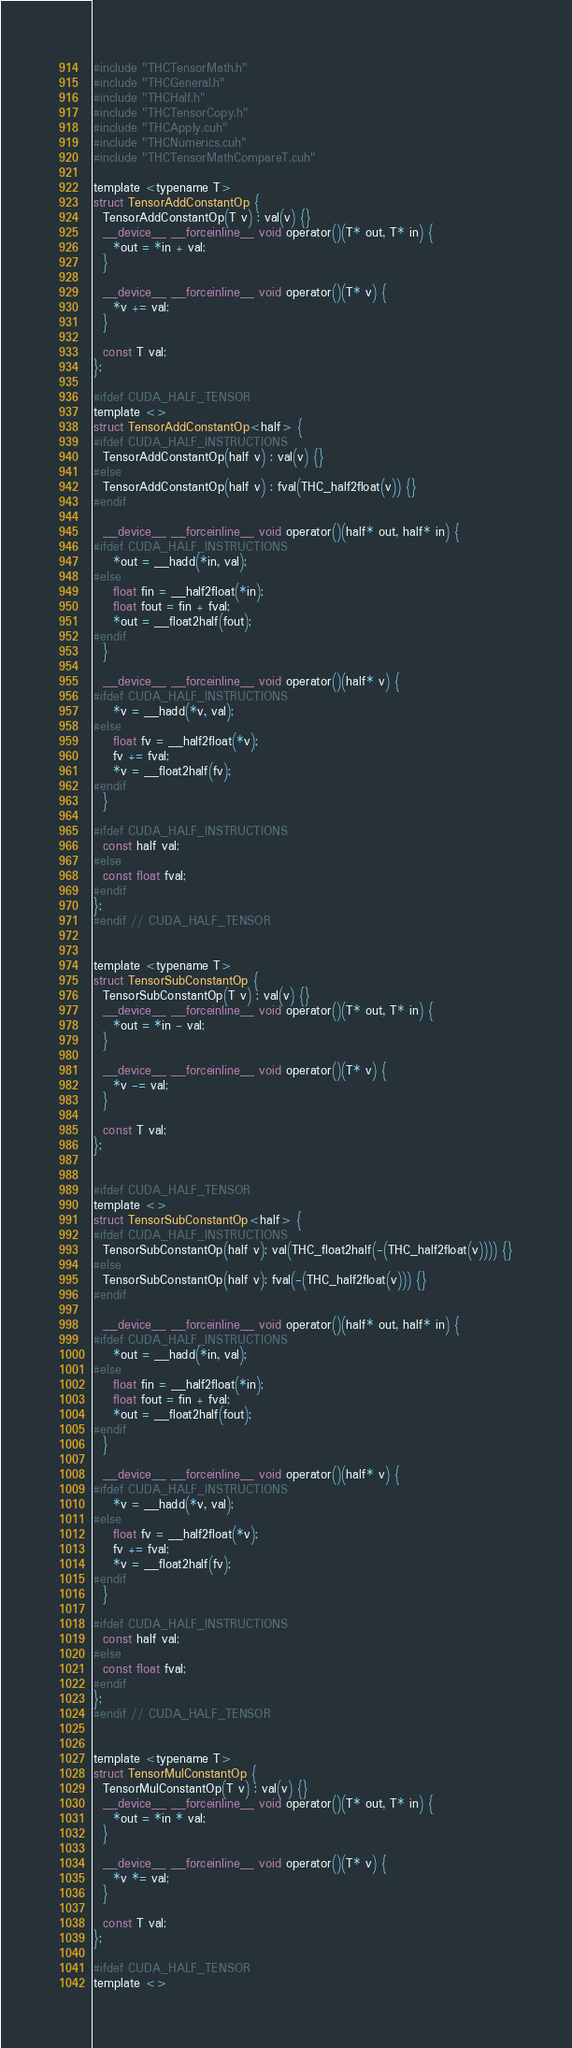<code> <loc_0><loc_0><loc_500><loc_500><_Cuda_>#include "THCTensorMath.h"
#include "THCGeneral.h"
#include "THCHalf.h"
#include "THCTensorCopy.h"
#include "THCApply.cuh"
#include "THCNumerics.cuh"
#include "THCTensorMathCompareT.cuh"

template <typename T>
struct TensorAddConstantOp {
  TensorAddConstantOp(T v) : val(v) {}
  __device__ __forceinline__ void operator()(T* out, T* in) {
    *out = *in + val;
  }

  __device__ __forceinline__ void operator()(T* v) {
    *v += val;
  }

  const T val;
};

#ifdef CUDA_HALF_TENSOR
template <>
struct TensorAddConstantOp<half> {
#ifdef CUDA_HALF_INSTRUCTIONS
  TensorAddConstantOp(half v) : val(v) {}
#else
  TensorAddConstantOp(half v) : fval(THC_half2float(v)) {}
#endif

  __device__ __forceinline__ void operator()(half* out, half* in) {
#ifdef CUDA_HALF_INSTRUCTIONS
    *out = __hadd(*in, val);
#else
    float fin = __half2float(*in);
    float fout = fin + fval;
    *out = __float2half(fout);
#endif
  }

  __device__ __forceinline__ void operator()(half* v) {
#ifdef CUDA_HALF_INSTRUCTIONS
    *v = __hadd(*v, val);
#else
    float fv = __half2float(*v);
    fv += fval;
    *v = __float2half(fv);
#endif
  }

#ifdef CUDA_HALF_INSTRUCTIONS
  const half val;
#else
  const float fval;
#endif
};
#endif // CUDA_HALF_TENSOR


template <typename T>
struct TensorSubConstantOp {
  TensorSubConstantOp(T v) : val(v) {}
  __device__ __forceinline__ void operator()(T* out, T* in) {
    *out = *in - val;
  }

  __device__ __forceinline__ void operator()(T* v) {
    *v -= val;
  }

  const T val;
};


#ifdef CUDA_HALF_TENSOR
template <>
struct TensorSubConstantOp<half> {
#ifdef CUDA_HALF_INSTRUCTIONS
  TensorSubConstantOp(half v): val(THC_float2half(-(THC_half2float(v)))) {}
#else
  TensorSubConstantOp(half v): fval(-(THC_half2float(v))) {}
#endif

  __device__ __forceinline__ void operator()(half* out, half* in) {
#ifdef CUDA_HALF_INSTRUCTIONS
    *out = __hadd(*in, val);
#else
    float fin = __half2float(*in);
    float fout = fin + fval;
    *out = __float2half(fout);
#endif
  }

  __device__ __forceinline__ void operator()(half* v) {
#ifdef CUDA_HALF_INSTRUCTIONS
    *v = __hadd(*v, val);
#else
    float fv = __half2float(*v);
    fv += fval;
    *v = __float2half(fv);
#endif
  }

#ifdef CUDA_HALF_INSTRUCTIONS
  const half val;
#else
  const float fval;
#endif
};
#endif // CUDA_HALF_TENSOR


template <typename T>
struct TensorMulConstantOp {
  TensorMulConstantOp(T v) : val(v) {}
  __device__ __forceinline__ void operator()(T* out, T* in) {
    *out = *in * val;
  }

  __device__ __forceinline__ void operator()(T* v) {
    *v *= val;
  }

  const T val;
};

#ifdef CUDA_HALF_TENSOR
template <></code> 